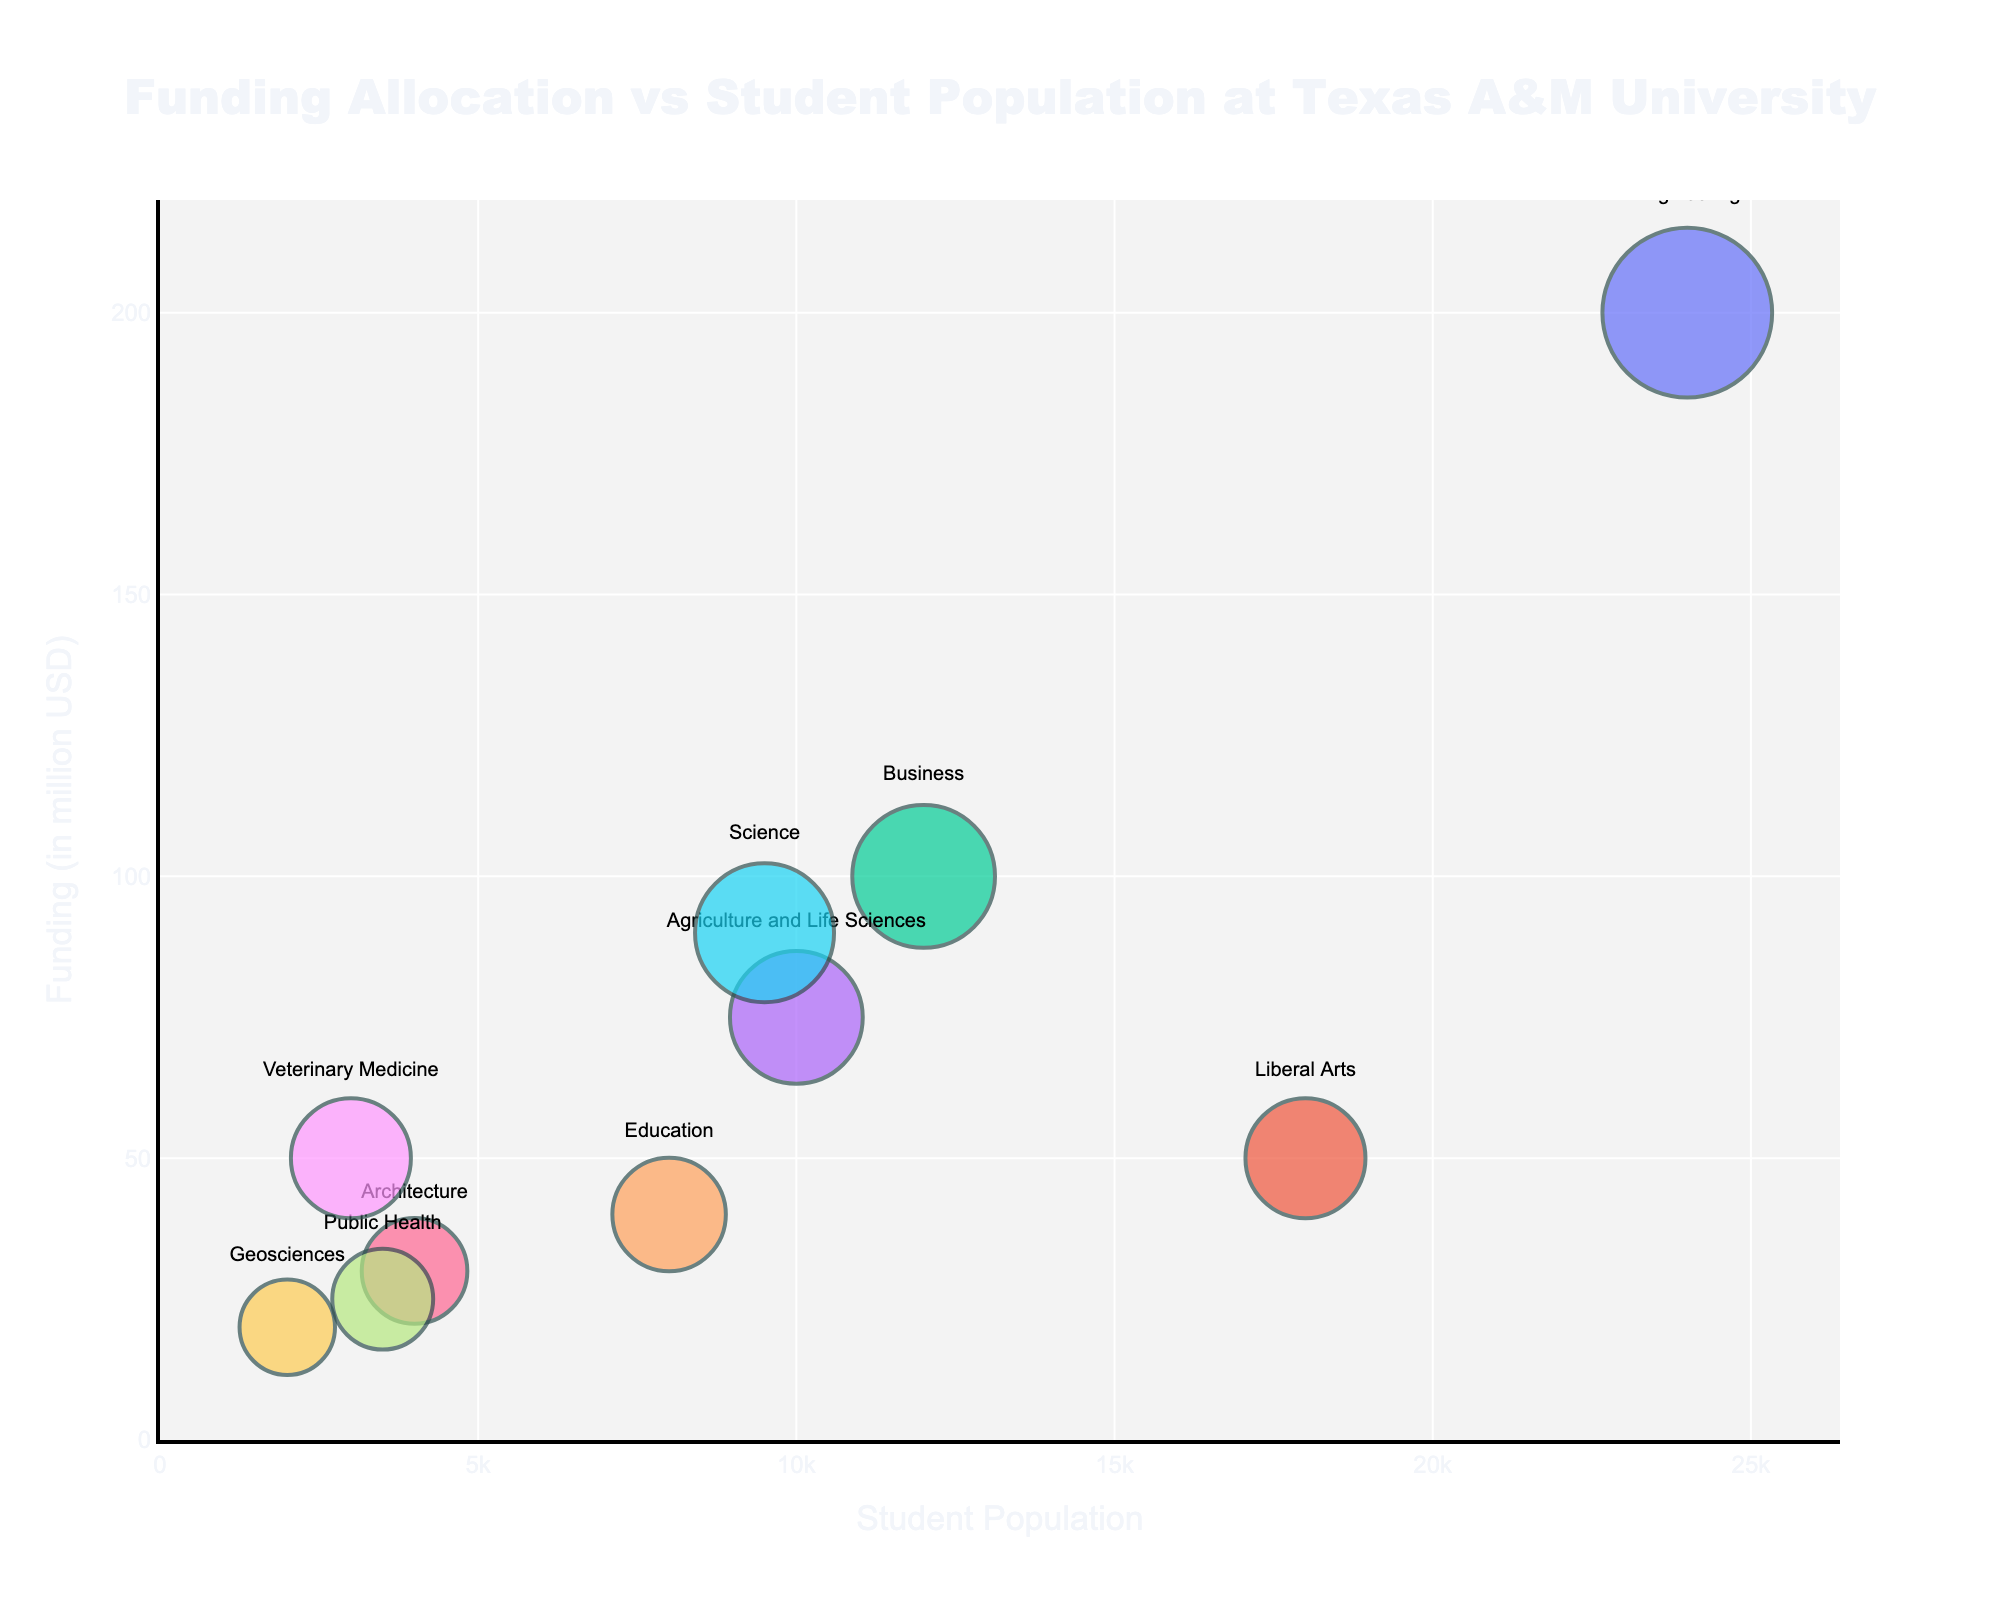what's the title of the figure? The title of the figure is usually displayed prominently at the top. In this case, it is "Funding Allocation vs Student Population at Texas A&M University"
Answer: Funding Allocation vs Student Population at Texas A&M University Which department has the highest funding? The department with the highest funding will be represented by the largest bubble on the y-axis. In this case, it is Engineering with 200 million USD
Answer: Engineering What is the student population of the Business department? Locate the bubble representing the Business department and check its x-axis value. The student population for Business is 12,000
Answer: 12,000 How does the funding for the Liberal Arts department compare to the Architecture department? Look at the y-axis values for both departments. The Liberal Arts department has 50 million USD, while the Architecture department has 30 million USD. Liberal Arts has more funding
Answer: Liberal Arts has more funding Which department has the smallest student population and what is it? Find the bubble closest to the left side of the x-axis. This is the Geosciences department with a student population of 2,000
Answer: Geosciences, 2,000 What is the average funding for all departments? Sum all the funding values and divide by the number of departments. (200 + 50 + 100 + 75 + 40 + 90 + 30 + 25 + 50 + 20) / 10 = 68 million USD
Answer: 68 million USD Which department has more students: Science or Agriculture and Life Sciences? Compare the x-axis values for Science (9,500) and Agriculture and Life Sciences (10,000). Agriculture and Life Sciences has more students
Answer: Agriculture and Life Sciences How many departments have a funding of at least 50 million USD? Identify the bubbles with y-axis values of 50 million USD or more. The departments are Engineering, Liberal Arts, Business, Science, and Veterinary Medicine, totaling 5 departments
Answer: 5 departments What is the total student population for departments with less than 40 million USD in funding? Sum the student populations for departments with funding values less than 40 million USD: Architecture (4,000), Public Health (3,500), Geosciences (2,000); 4,000 + 3,500 + 2,000 = 9,500
Answer: 9,500 Which department has a higher funding per student: Liberal Arts or Engineering? Calculate funding per student for both departments: Liberal Arts (50 million / 18,000 ≈ 2.78 thousand USD) and Engineering (200 million / 24,000 ≈ 8.33 thousand USD). Engineering has a higher funding per student
Answer: Engineering 